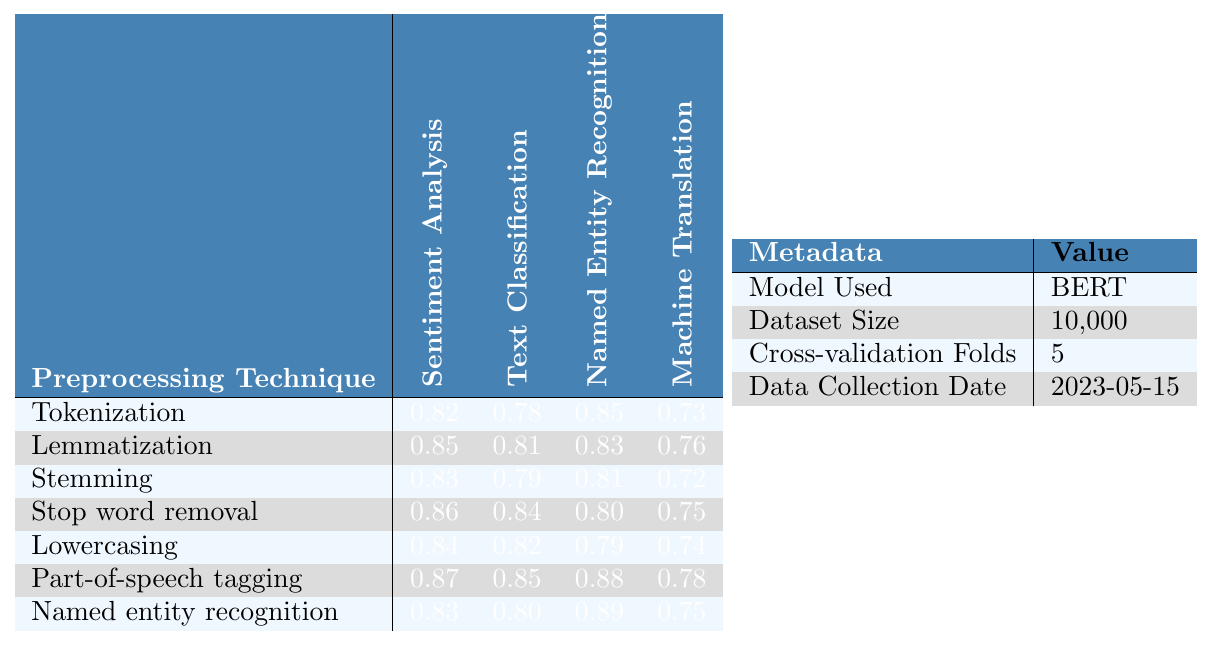What is the cross-validation score for Stemming in Named Entity Recognition? The table shows that the score for Stemming in Named Entity Recognition is 0.81.
Answer: 0.81 Which preprocessing technique had the highest cross-validation score in Sentiment Analysis? By comparing the scores for all techniques in Sentiment Analysis, Stop word removal has the highest score of 0.86.
Answer: Stop word removal What is the average cross-validation score for Lemmatization across all tasks? The scores for Lemmatization are 0.85, 0.81, 0.83, and 0.76. Adding these gives 3.25, and dividing by 4 (the number of tasks) gives an average of 0.8125.
Answer: 0.8125 Did Part-of-speech tagging perform better in Text Classification than Named entity recognition? The scores for Part-of-speech tagging in Text Classification (0.85) and Named entity recognition (0.88) show that Named entity recognition had a higher score, so the answer is no.
Answer: No Which preprocessing technique had the lowest score in Machine Translation? The scores for Machine Translation show that Stemming has the lowest score of 0.72.
Answer: Stemming What is the difference between the highest and lowest scores for Named Entity Recognition across all preprocessing techniques? The highest score for Named Entity Recognition is 0.89 (Named entity recognition), and the lowest is 0.80 (Stop word removal). The difference is 0.89 - 0.80 = 0.09.
Answer: 0.09 How does the cross-validation score of Lowercasing in Sentiment Analysis compare to that of Tokenization? The score for Lowercasing in Sentiment Analysis is 0.84, and for Tokenization, it's 0.82. Lowercasing has a higher score, making it better in this case.
Answer: Lowercasing performs better Which technique has a score of 0.76 in Machine Translation? Examining the scores for Machine Translation reveals that Lemmatization has a score of 0.76.
Answer: Lemmatization If we consider the scores for Stop word removal and Stemming in Text Classification, which one is higher? Looking at the table, Stop word removal has a score of 0.84 while Stemming has 0.79, thus Stop word removal is higher.
Answer: Stop word removal What is the combined score for Tokenization and Lemmatization in Sentiment Analysis? The scores for Tokenization (0.82) and Lemmatization (0.85) sum up to 0.82 + 0.85 = 1.67.
Answer: 1.67 